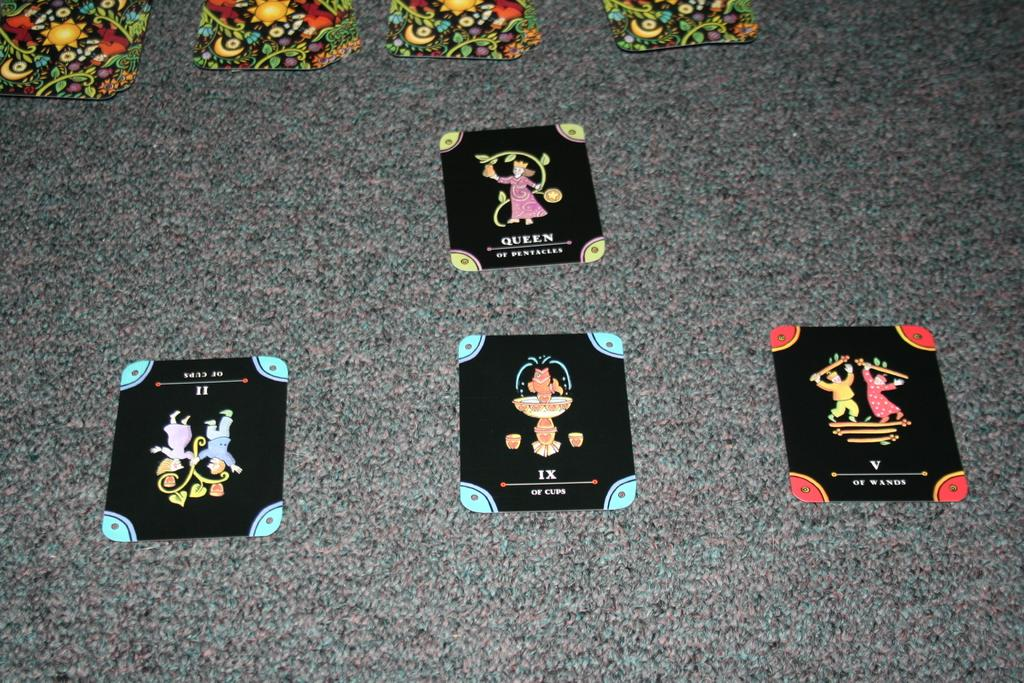What objects are present in the image? There are cards in the image. Where are the cards located? The cards are placed on a platform. What type of fear can be seen on the cards in the image? There is no fear depicted on the cards in the image; they are simply cards placed on a platform. 